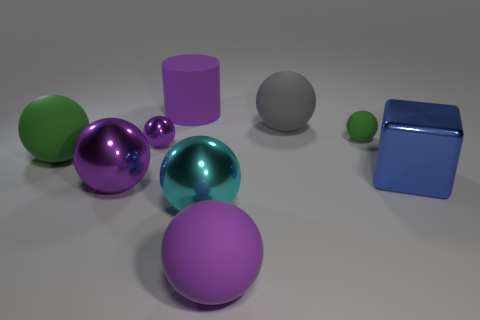Are there more purple cylinders to the left of the large cyan thing than yellow matte objects?
Give a very brief answer. Yes. How many objects are either small red shiny blocks or large purple things in front of the blue object?
Provide a succinct answer. 2. Is the number of matte things to the left of the big purple cylinder greater than the number of big purple shiny balls behind the large gray rubber ball?
Offer a terse response. Yes. What is the material of the purple sphere that is behind the green thing that is left of the purple shiny thing that is in front of the small purple shiny sphere?
Give a very brief answer. Metal. What is the shape of the blue object that is made of the same material as the big cyan sphere?
Ensure brevity in your answer.  Cube. Is there a large blue metallic block to the right of the large blue metallic object in front of the big green matte sphere?
Provide a succinct answer. No. What is the size of the cube?
Provide a short and direct response. Large. What number of things are cylinders or large balls?
Ensure brevity in your answer.  6. Does the purple sphere on the right side of the tiny purple ball have the same material as the ball that is left of the large purple metallic sphere?
Your response must be concise. Yes. What is the color of the big cube that is the same material as the cyan thing?
Provide a short and direct response. Blue. 